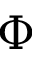Convert formula to latex. <formula><loc_0><loc_0><loc_500><loc_500>\Phi</formula> 